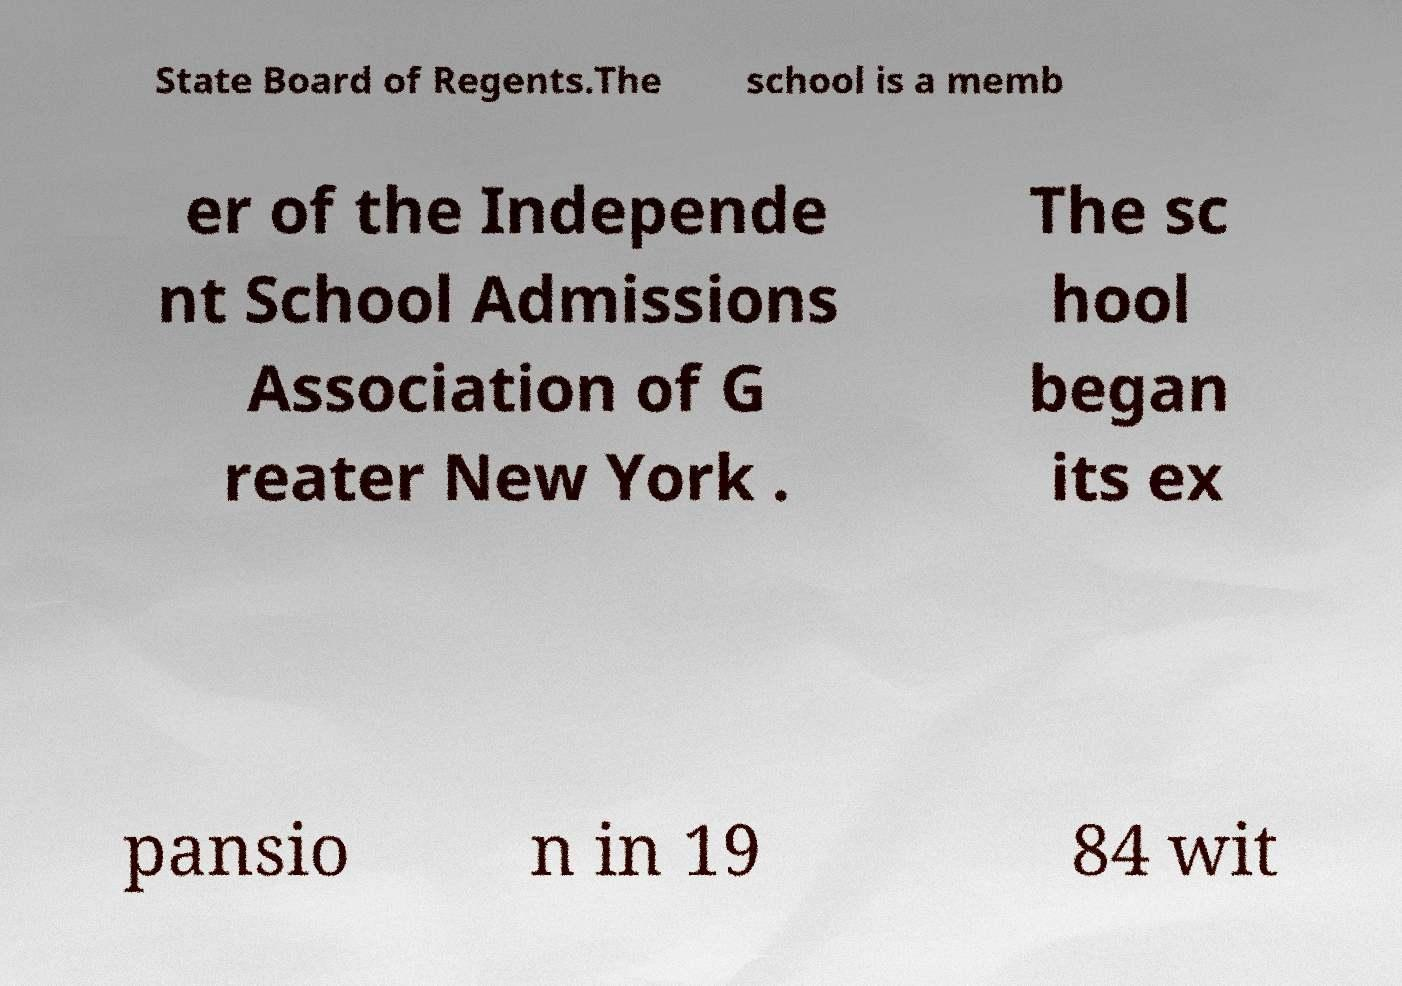There's text embedded in this image that I need extracted. Can you transcribe it verbatim? State Board of Regents.The school is a memb er of the Independe nt School Admissions Association of G reater New York . The sc hool began its ex pansio n in 19 84 wit 